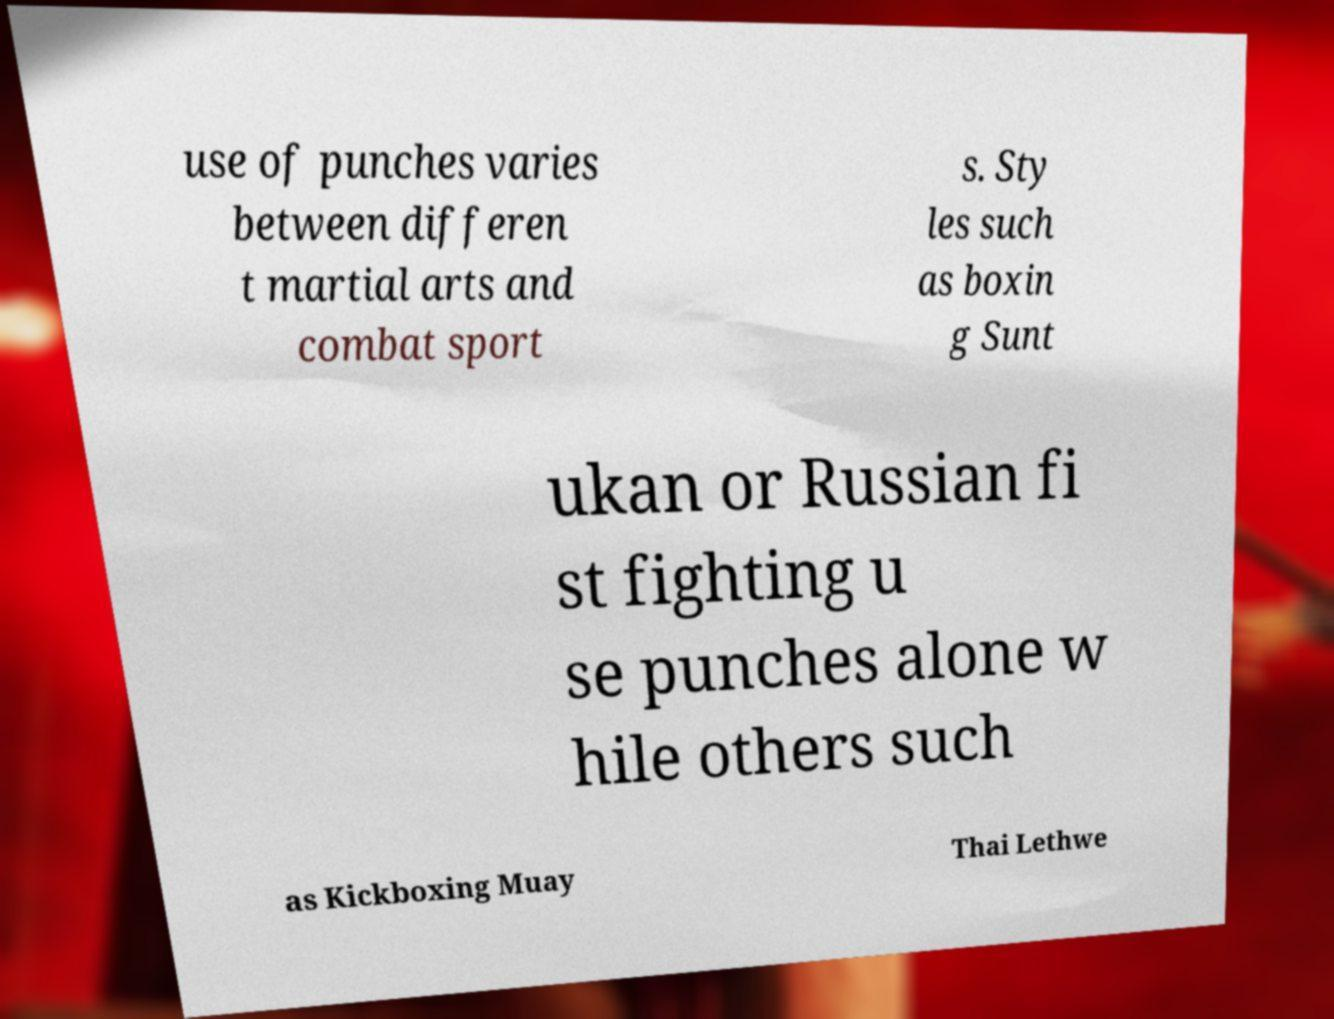For documentation purposes, I need the text within this image transcribed. Could you provide that? use of punches varies between differen t martial arts and combat sport s. Sty les such as boxin g Sunt ukan or Russian fi st fighting u se punches alone w hile others such as Kickboxing Muay Thai Lethwe 